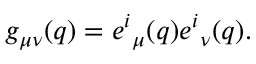<formula> <loc_0><loc_0><loc_500><loc_500>g _ { \mu \nu } ( q ) = e ^ { i _ { \mu } ( q ) e ^ { i _ { \nu } ( q ) .</formula> 